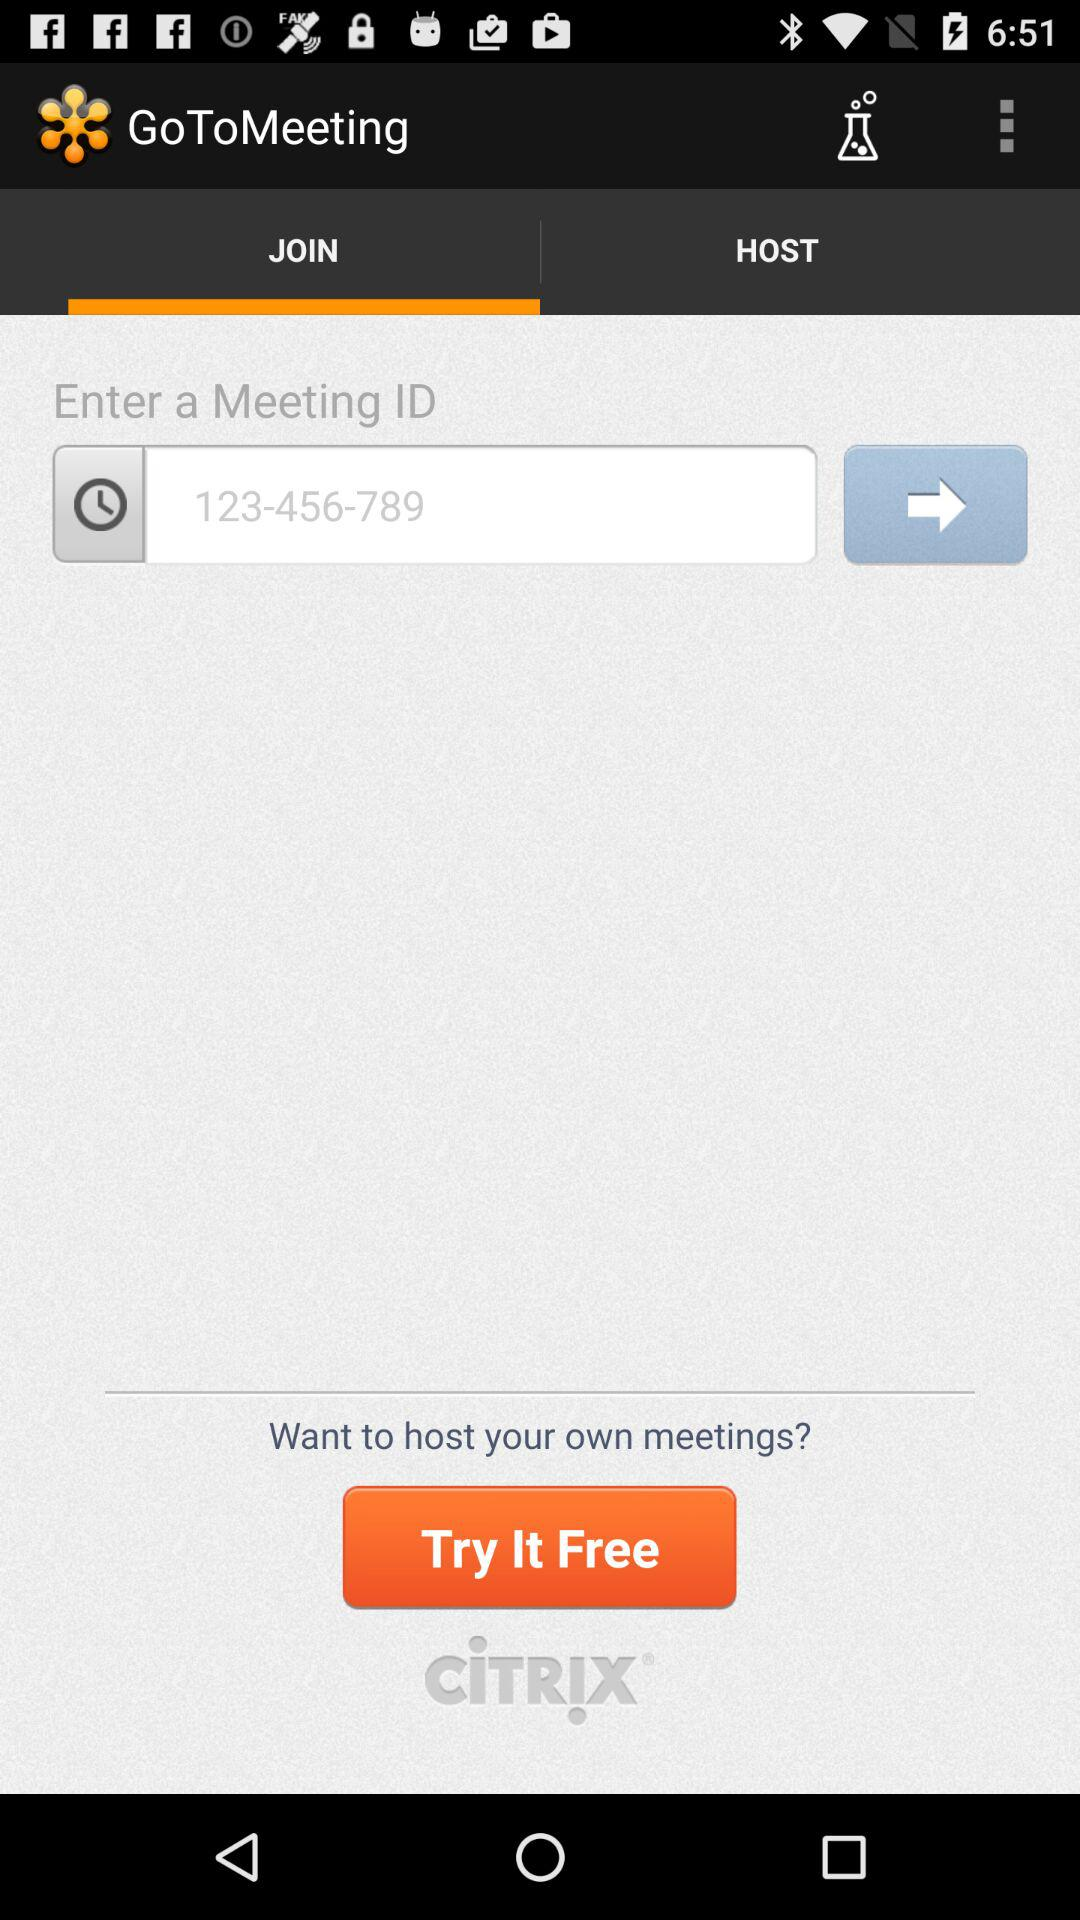What is the selected tab? The selected tab is "JOIN". 